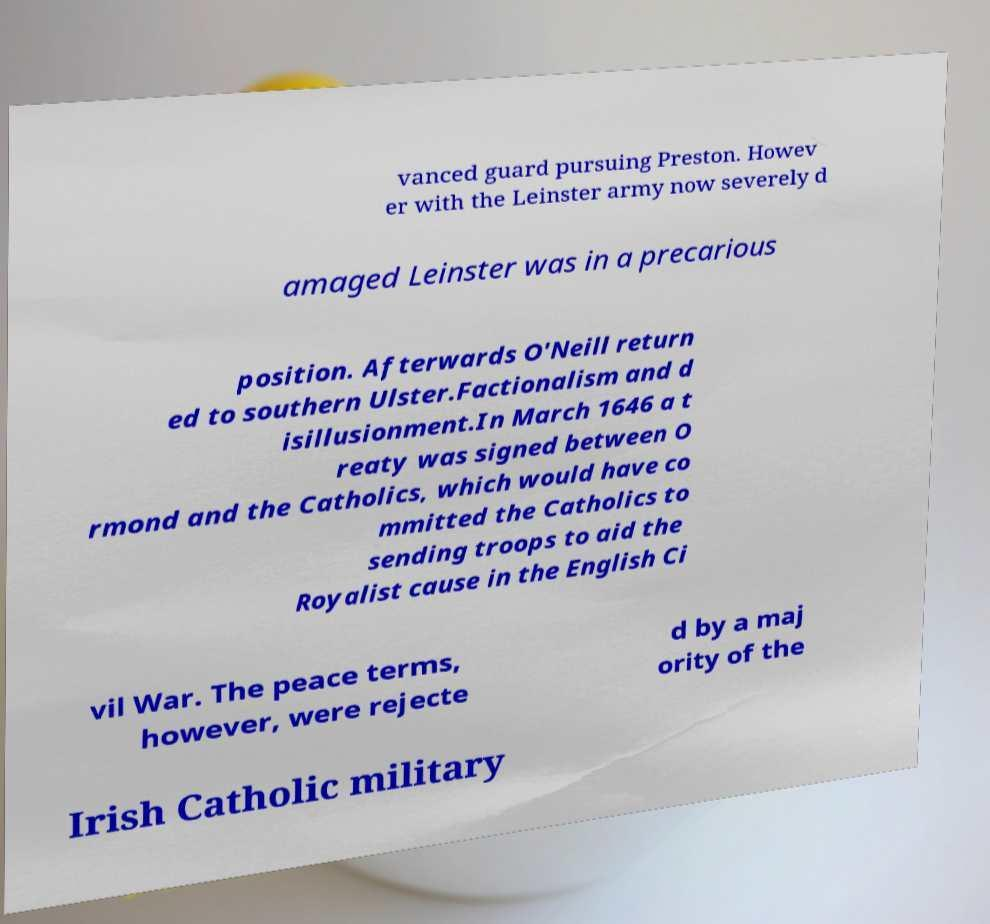For documentation purposes, I need the text within this image transcribed. Could you provide that? vanced guard pursuing Preston. Howev er with the Leinster army now severely d amaged Leinster was in a precarious position. Afterwards O'Neill return ed to southern Ulster.Factionalism and d isillusionment.In March 1646 a t reaty was signed between O rmond and the Catholics, which would have co mmitted the Catholics to sending troops to aid the Royalist cause in the English Ci vil War. The peace terms, however, were rejecte d by a maj ority of the Irish Catholic military 